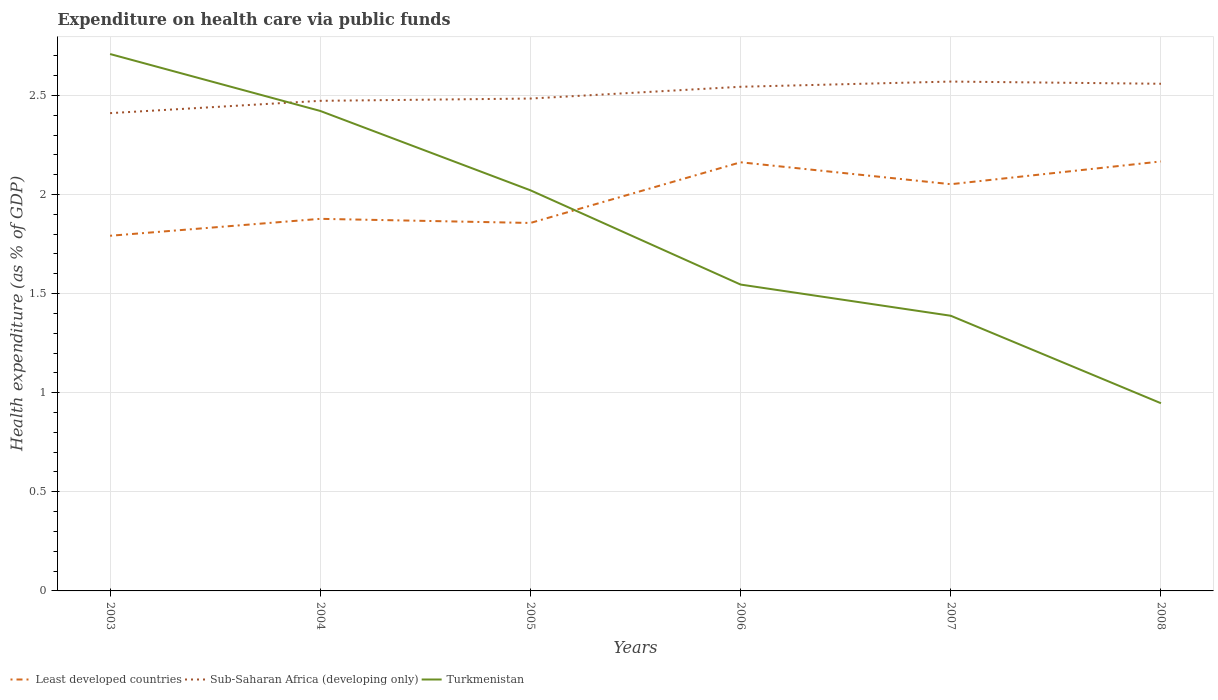How many different coloured lines are there?
Provide a short and direct response. 3. Does the line corresponding to Least developed countries intersect with the line corresponding to Sub-Saharan Africa (developing only)?
Your answer should be compact. No. Is the number of lines equal to the number of legend labels?
Offer a very short reply. Yes. Across all years, what is the maximum expenditure made on health care in Turkmenistan?
Keep it short and to the point. 0.95. What is the total expenditure made on health care in Least developed countries in the graph?
Provide a succinct answer. -0.37. What is the difference between the highest and the second highest expenditure made on health care in Least developed countries?
Make the answer very short. 0.37. Is the expenditure made on health care in Sub-Saharan Africa (developing only) strictly greater than the expenditure made on health care in Turkmenistan over the years?
Offer a very short reply. No. How many lines are there?
Keep it short and to the point. 3. Are the values on the major ticks of Y-axis written in scientific E-notation?
Keep it short and to the point. No. How many legend labels are there?
Provide a succinct answer. 3. What is the title of the graph?
Offer a very short reply. Expenditure on health care via public funds. Does "North America" appear as one of the legend labels in the graph?
Offer a terse response. No. What is the label or title of the X-axis?
Make the answer very short. Years. What is the label or title of the Y-axis?
Your response must be concise. Health expenditure (as % of GDP). What is the Health expenditure (as % of GDP) of Least developed countries in 2003?
Give a very brief answer. 1.79. What is the Health expenditure (as % of GDP) in Sub-Saharan Africa (developing only) in 2003?
Offer a very short reply. 2.41. What is the Health expenditure (as % of GDP) in Turkmenistan in 2003?
Ensure brevity in your answer.  2.71. What is the Health expenditure (as % of GDP) in Least developed countries in 2004?
Give a very brief answer. 1.88. What is the Health expenditure (as % of GDP) of Sub-Saharan Africa (developing only) in 2004?
Give a very brief answer. 2.47. What is the Health expenditure (as % of GDP) of Turkmenistan in 2004?
Make the answer very short. 2.42. What is the Health expenditure (as % of GDP) in Least developed countries in 2005?
Ensure brevity in your answer.  1.86. What is the Health expenditure (as % of GDP) in Sub-Saharan Africa (developing only) in 2005?
Provide a short and direct response. 2.48. What is the Health expenditure (as % of GDP) of Turkmenistan in 2005?
Provide a short and direct response. 2.02. What is the Health expenditure (as % of GDP) of Least developed countries in 2006?
Make the answer very short. 2.16. What is the Health expenditure (as % of GDP) of Sub-Saharan Africa (developing only) in 2006?
Your answer should be compact. 2.54. What is the Health expenditure (as % of GDP) in Turkmenistan in 2006?
Your answer should be very brief. 1.55. What is the Health expenditure (as % of GDP) in Least developed countries in 2007?
Ensure brevity in your answer.  2.05. What is the Health expenditure (as % of GDP) in Sub-Saharan Africa (developing only) in 2007?
Provide a short and direct response. 2.57. What is the Health expenditure (as % of GDP) in Turkmenistan in 2007?
Offer a very short reply. 1.39. What is the Health expenditure (as % of GDP) in Least developed countries in 2008?
Provide a short and direct response. 2.17. What is the Health expenditure (as % of GDP) in Sub-Saharan Africa (developing only) in 2008?
Give a very brief answer. 2.56. What is the Health expenditure (as % of GDP) in Turkmenistan in 2008?
Your answer should be very brief. 0.95. Across all years, what is the maximum Health expenditure (as % of GDP) in Least developed countries?
Keep it short and to the point. 2.17. Across all years, what is the maximum Health expenditure (as % of GDP) of Sub-Saharan Africa (developing only)?
Provide a succinct answer. 2.57. Across all years, what is the maximum Health expenditure (as % of GDP) of Turkmenistan?
Offer a very short reply. 2.71. Across all years, what is the minimum Health expenditure (as % of GDP) of Least developed countries?
Give a very brief answer. 1.79. Across all years, what is the minimum Health expenditure (as % of GDP) of Sub-Saharan Africa (developing only)?
Provide a succinct answer. 2.41. Across all years, what is the minimum Health expenditure (as % of GDP) of Turkmenistan?
Your answer should be compact. 0.95. What is the total Health expenditure (as % of GDP) of Least developed countries in the graph?
Your answer should be very brief. 11.91. What is the total Health expenditure (as % of GDP) of Sub-Saharan Africa (developing only) in the graph?
Keep it short and to the point. 15.04. What is the total Health expenditure (as % of GDP) of Turkmenistan in the graph?
Provide a succinct answer. 11.03. What is the difference between the Health expenditure (as % of GDP) in Least developed countries in 2003 and that in 2004?
Ensure brevity in your answer.  -0.09. What is the difference between the Health expenditure (as % of GDP) in Sub-Saharan Africa (developing only) in 2003 and that in 2004?
Give a very brief answer. -0.06. What is the difference between the Health expenditure (as % of GDP) in Turkmenistan in 2003 and that in 2004?
Offer a terse response. 0.29. What is the difference between the Health expenditure (as % of GDP) in Least developed countries in 2003 and that in 2005?
Keep it short and to the point. -0.06. What is the difference between the Health expenditure (as % of GDP) of Sub-Saharan Africa (developing only) in 2003 and that in 2005?
Provide a succinct answer. -0.07. What is the difference between the Health expenditure (as % of GDP) in Turkmenistan in 2003 and that in 2005?
Offer a terse response. 0.69. What is the difference between the Health expenditure (as % of GDP) in Least developed countries in 2003 and that in 2006?
Provide a short and direct response. -0.37. What is the difference between the Health expenditure (as % of GDP) of Sub-Saharan Africa (developing only) in 2003 and that in 2006?
Your response must be concise. -0.13. What is the difference between the Health expenditure (as % of GDP) of Turkmenistan in 2003 and that in 2006?
Keep it short and to the point. 1.16. What is the difference between the Health expenditure (as % of GDP) of Least developed countries in 2003 and that in 2007?
Provide a short and direct response. -0.26. What is the difference between the Health expenditure (as % of GDP) in Sub-Saharan Africa (developing only) in 2003 and that in 2007?
Keep it short and to the point. -0.16. What is the difference between the Health expenditure (as % of GDP) of Turkmenistan in 2003 and that in 2007?
Make the answer very short. 1.32. What is the difference between the Health expenditure (as % of GDP) of Least developed countries in 2003 and that in 2008?
Your response must be concise. -0.37. What is the difference between the Health expenditure (as % of GDP) in Sub-Saharan Africa (developing only) in 2003 and that in 2008?
Ensure brevity in your answer.  -0.15. What is the difference between the Health expenditure (as % of GDP) of Turkmenistan in 2003 and that in 2008?
Give a very brief answer. 1.76. What is the difference between the Health expenditure (as % of GDP) of Least developed countries in 2004 and that in 2005?
Give a very brief answer. 0.02. What is the difference between the Health expenditure (as % of GDP) of Sub-Saharan Africa (developing only) in 2004 and that in 2005?
Your answer should be compact. -0.01. What is the difference between the Health expenditure (as % of GDP) in Turkmenistan in 2004 and that in 2005?
Keep it short and to the point. 0.4. What is the difference between the Health expenditure (as % of GDP) in Least developed countries in 2004 and that in 2006?
Your answer should be compact. -0.29. What is the difference between the Health expenditure (as % of GDP) in Sub-Saharan Africa (developing only) in 2004 and that in 2006?
Provide a short and direct response. -0.07. What is the difference between the Health expenditure (as % of GDP) in Turkmenistan in 2004 and that in 2006?
Provide a short and direct response. 0.88. What is the difference between the Health expenditure (as % of GDP) in Least developed countries in 2004 and that in 2007?
Provide a short and direct response. -0.17. What is the difference between the Health expenditure (as % of GDP) in Sub-Saharan Africa (developing only) in 2004 and that in 2007?
Your response must be concise. -0.1. What is the difference between the Health expenditure (as % of GDP) of Least developed countries in 2004 and that in 2008?
Make the answer very short. -0.29. What is the difference between the Health expenditure (as % of GDP) in Sub-Saharan Africa (developing only) in 2004 and that in 2008?
Provide a short and direct response. -0.09. What is the difference between the Health expenditure (as % of GDP) of Turkmenistan in 2004 and that in 2008?
Make the answer very short. 1.47. What is the difference between the Health expenditure (as % of GDP) in Least developed countries in 2005 and that in 2006?
Offer a terse response. -0.31. What is the difference between the Health expenditure (as % of GDP) of Sub-Saharan Africa (developing only) in 2005 and that in 2006?
Offer a terse response. -0.06. What is the difference between the Health expenditure (as % of GDP) of Turkmenistan in 2005 and that in 2006?
Keep it short and to the point. 0.48. What is the difference between the Health expenditure (as % of GDP) in Least developed countries in 2005 and that in 2007?
Your answer should be compact. -0.2. What is the difference between the Health expenditure (as % of GDP) in Sub-Saharan Africa (developing only) in 2005 and that in 2007?
Make the answer very short. -0.09. What is the difference between the Health expenditure (as % of GDP) in Turkmenistan in 2005 and that in 2007?
Your response must be concise. 0.63. What is the difference between the Health expenditure (as % of GDP) of Least developed countries in 2005 and that in 2008?
Your response must be concise. -0.31. What is the difference between the Health expenditure (as % of GDP) in Sub-Saharan Africa (developing only) in 2005 and that in 2008?
Keep it short and to the point. -0.07. What is the difference between the Health expenditure (as % of GDP) of Turkmenistan in 2005 and that in 2008?
Make the answer very short. 1.07. What is the difference between the Health expenditure (as % of GDP) of Least developed countries in 2006 and that in 2007?
Provide a short and direct response. 0.11. What is the difference between the Health expenditure (as % of GDP) in Sub-Saharan Africa (developing only) in 2006 and that in 2007?
Provide a short and direct response. -0.03. What is the difference between the Health expenditure (as % of GDP) in Turkmenistan in 2006 and that in 2007?
Offer a very short reply. 0.16. What is the difference between the Health expenditure (as % of GDP) in Least developed countries in 2006 and that in 2008?
Your response must be concise. -0. What is the difference between the Health expenditure (as % of GDP) in Sub-Saharan Africa (developing only) in 2006 and that in 2008?
Provide a short and direct response. -0.02. What is the difference between the Health expenditure (as % of GDP) of Turkmenistan in 2006 and that in 2008?
Your answer should be compact. 0.6. What is the difference between the Health expenditure (as % of GDP) in Least developed countries in 2007 and that in 2008?
Your answer should be very brief. -0.11. What is the difference between the Health expenditure (as % of GDP) in Sub-Saharan Africa (developing only) in 2007 and that in 2008?
Provide a short and direct response. 0.01. What is the difference between the Health expenditure (as % of GDP) of Turkmenistan in 2007 and that in 2008?
Ensure brevity in your answer.  0.44. What is the difference between the Health expenditure (as % of GDP) of Least developed countries in 2003 and the Health expenditure (as % of GDP) of Sub-Saharan Africa (developing only) in 2004?
Provide a short and direct response. -0.68. What is the difference between the Health expenditure (as % of GDP) of Least developed countries in 2003 and the Health expenditure (as % of GDP) of Turkmenistan in 2004?
Your answer should be compact. -0.63. What is the difference between the Health expenditure (as % of GDP) of Sub-Saharan Africa (developing only) in 2003 and the Health expenditure (as % of GDP) of Turkmenistan in 2004?
Ensure brevity in your answer.  -0.01. What is the difference between the Health expenditure (as % of GDP) of Least developed countries in 2003 and the Health expenditure (as % of GDP) of Sub-Saharan Africa (developing only) in 2005?
Offer a very short reply. -0.69. What is the difference between the Health expenditure (as % of GDP) of Least developed countries in 2003 and the Health expenditure (as % of GDP) of Turkmenistan in 2005?
Provide a succinct answer. -0.23. What is the difference between the Health expenditure (as % of GDP) in Sub-Saharan Africa (developing only) in 2003 and the Health expenditure (as % of GDP) in Turkmenistan in 2005?
Make the answer very short. 0.39. What is the difference between the Health expenditure (as % of GDP) of Least developed countries in 2003 and the Health expenditure (as % of GDP) of Sub-Saharan Africa (developing only) in 2006?
Provide a short and direct response. -0.75. What is the difference between the Health expenditure (as % of GDP) in Least developed countries in 2003 and the Health expenditure (as % of GDP) in Turkmenistan in 2006?
Give a very brief answer. 0.25. What is the difference between the Health expenditure (as % of GDP) in Sub-Saharan Africa (developing only) in 2003 and the Health expenditure (as % of GDP) in Turkmenistan in 2006?
Ensure brevity in your answer.  0.86. What is the difference between the Health expenditure (as % of GDP) in Least developed countries in 2003 and the Health expenditure (as % of GDP) in Sub-Saharan Africa (developing only) in 2007?
Ensure brevity in your answer.  -0.78. What is the difference between the Health expenditure (as % of GDP) of Least developed countries in 2003 and the Health expenditure (as % of GDP) of Turkmenistan in 2007?
Offer a very short reply. 0.4. What is the difference between the Health expenditure (as % of GDP) of Sub-Saharan Africa (developing only) in 2003 and the Health expenditure (as % of GDP) of Turkmenistan in 2007?
Offer a very short reply. 1.02. What is the difference between the Health expenditure (as % of GDP) of Least developed countries in 2003 and the Health expenditure (as % of GDP) of Sub-Saharan Africa (developing only) in 2008?
Provide a succinct answer. -0.77. What is the difference between the Health expenditure (as % of GDP) in Least developed countries in 2003 and the Health expenditure (as % of GDP) in Turkmenistan in 2008?
Provide a short and direct response. 0.84. What is the difference between the Health expenditure (as % of GDP) of Sub-Saharan Africa (developing only) in 2003 and the Health expenditure (as % of GDP) of Turkmenistan in 2008?
Your answer should be very brief. 1.46. What is the difference between the Health expenditure (as % of GDP) of Least developed countries in 2004 and the Health expenditure (as % of GDP) of Sub-Saharan Africa (developing only) in 2005?
Make the answer very short. -0.61. What is the difference between the Health expenditure (as % of GDP) in Least developed countries in 2004 and the Health expenditure (as % of GDP) in Turkmenistan in 2005?
Ensure brevity in your answer.  -0.14. What is the difference between the Health expenditure (as % of GDP) in Sub-Saharan Africa (developing only) in 2004 and the Health expenditure (as % of GDP) in Turkmenistan in 2005?
Offer a very short reply. 0.45. What is the difference between the Health expenditure (as % of GDP) in Least developed countries in 2004 and the Health expenditure (as % of GDP) in Sub-Saharan Africa (developing only) in 2006?
Provide a short and direct response. -0.67. What is the difference between the Health expenditure (as % of GDP) of Least developed countries in 2004 and the Health expenditure (as % of GDP) of Turkmenistan in 2006?
Offer a very short reply. 0.33. What is the difference between the Health expenditure (as % of GDP) of Sub-Saharan Africa (developing only) in 2004 and the Health expenditure (as % of GDP) of Turkmenistan in 2006?
Give a very brief answer. 0.93. What is the difference between the Health expenditure (as % of GDP) in Least developed countries in 2004 and the Health expenditure (as % of GDP) in Sub-Saharan Africa (developing only) in 2007?
Make the answer very short. -0.69. What is the difference between the Health expenditure (as % of GDP) in Least developed countries in 2004 and the Health expenditure (as % of GDP) in Turkmenistan in 2007?
Provide a short and direct response. 0.49. What is the difference between the Health expenditure (as % of GDP) of Sub-Saharan Africa (developing only) in 2004 and the Health expenditure (as % of GDP) of Turkmenistan in 2007?
Provide a succinct answer. 1.08. What is the difference between the Health expenditure (as % of GDP) in Least developed countries in 2004 and the Health expenditure (as % of GDP) in Sub-Saharan Africa (developing only) in 2008?
Make the answer very short. -0.68. What is the difference between the Health expenditure (as % of GDP) in Least developed countries in 2004 and the Health expenditure (as % of GDP) in Turkmenistan in 2008?
Offer a very short reply. 0.93. What is the difference between the Health expenditure (as % of GDP) in Sub-Saharan Africa (developing only) in 2004 and the Health expenditure (as % of GDP) in Turkmenistan in 2008?
Offer a terse response. 1.53. What is the difference between the Health expenditure (as % of GDP) in Least developed countries in 2005 and the Health expenditure (as % of GDP) in Sub-Saharan Africa (developing only) in 2006?
Give a very brief answer. -0.69. What is the difference between the Health expenditure (as % of GDP) in Least developed countries in 2005 and the Health expenditure (as % of GDP) in Turkmenistan in 2006?
Ensure brevity in your answer.  0.31. What is the difference between the Health expenditure (as % of GDP) in Sub-Saharan Africa (developing only) in 2005 and the Health expenditure (as % of GDP) in Turkmenistan in 2006?
Your response must be concise. 0.94. What is the difference between the Health expenditure (as % of GDP) of Least developed countries in 2005 and the Health expenditure (as % of GDP) of Sub-Saharan Africa (developing only) in 2007?
Provide a succinct answer. -0.71. What is the difference between the Health expenditure (as % of GDP) of Least developed countries in 2005 and the Health expenditure (as % of GDP) of Turkmenistan in 2007?
Your answer should be compact. 0.47. What is the difference between the Health expenditure (as % of GDP) of Sub-Saharan Africa (developing only) in 2005 and the Health expenditure (as % of GDP) of Turkmenistan in 2007?
Offer a terse response. 1.1. What is the difference between the Health expenditure (as % of GDP) in Least developed countries in 2005 and the Health expenditure (as % of GDP) in Sub-Saharan Africa (developing only) in 2008?
Provide a succinct answer. -0.7. What is the difference between the Health expenditure (as % of GDP) of Least developed countries in 2005 and the Health expenditure (as % of GDP) of Turkmenistan in 2008?
Give a very brief answer. 0.91. What is the difference between the Health expenditure (as % of GDP) in Sub-Saharan Africa (developing only) in 2005 and the Health expenditure (as % of GDP) in Turkmenistan in 2008?
Your answer should be compact. 1.54. What is the difference between the Health expenditure (as % of GDP) in Least developed countries in 2006 and the Health expenditure (as % of GDP) in Sub-Saharan Africa (developing only) in 2007?
Your response must be concise. -0.41. What is the difference between the Health expenditure (as % of GDP) in Least developed countries in 2006 and the Health expenditure (as % of GDP) in Turkmenistan in 2007?
Offer a very short reply. 0.77. What is the difference between the Health expenditure (as % of GDP) in Sub-Saharan Africa (developing only) in 2006 and the Health expenditure (as % of GDP) in Turkmenistan in 2007?
Offer a terse response. 1.16. What is the difference between the Health expenditure (as % of GDP) of Least developed countries in 2006 and the Health expenditure (as % of GDP) of Sub-Saharan Africa (developing only) in 2008?
Your answer should be compact. -0.4. What is the difference between the Health expenditure (as % of GDP) in Least developed countries in 2006 and the Health expenditure (as % of GDP) in Turkmenistan in 2008?
Provide a short and direct response. 1.22. What is the difference between the Health expenditure (as % of GDP) in Sub-Saharan Africa (developing only) in 2006 and the Health expenditure (as % of GDP) in Turkmenistan in 2008?
Provide a short and direct response. 1.6. What is the difference between the Health expenditure (as % of GDP) of Least developed countries in 2007 and the Health expenditure (as % of GDP) of Sub-Saharan Africa (developing only) in 2008?
Offer a very short reply. -0.51. What is the difference between the Health expenditure (as % of GDP) of Least developed countries in 2007 and the Health expenditure (as % of GDP) of Turkmenistan in 2008?
Provide a short and direct response. 1.1. What is the difference between the Health expenditure (as % of GDP) in Sub-Saharan Africa (developing only) in 2007 and the Health expenditure (as % of GDP) in Turkmenistan in 2008?
Your response must be concise. 1.62. What is the average Health expenditure (as % of GDP) in Least developed countries per year?
Keep it short and to the point. 1.98. What is the average Health expenditure (as % of GDP) in Sub-Saharan Africa (developing only) per year?
Keep it short and to the point. 2.51. What is the average Health expenditure (as % of GDP) of Turkmenistan per year?
Make the answer very short. 1.84. In the year 2003, what is the difference between the Health expenditure (as % of GDP) of Least developed countries and Health expenditure (as % of GDP) of Sub-Saharan Africa (developing only)?
Offer a very short reply. -0.62. In the year 2003, what is the difference between the Health expenditure (as % of GDP) of Least developed countries and Health expenditure (as % of GDP) of Turkmenistan?
Your answer should be compact. -0.92. In the year 2003, what is the difference between the Health expenditure (as % of GDP) of Sub-Saharan Africa (developing only) and Health expenditure (as % of GDP) of Turkmenistan?
Keep it short and to the point. -0.3. In the year 2004, what is the difference between the Health expenditure (as % of GDP) in Least developed countries and Health expenditure (as % of GDP) in Sub-Saharan Africa (developing only)?
Your answer should be compact. -0.6. In the year 2004, what is the difference between the Health expenditure (as % of GDP) in Least developed countries and Health expenditure (as % of GDP) in Turkmenistan?
Your answer should be very brief. -0.54. In the year 2004, what is the difference between the Health expenditure (as % of GDP) of Sub-Saharan Africa (developing only) and Health expenditure (as % of GDP) of Turkmenistan?
Keep it short and to the point. 0.05. In the year 2005, what is the difference between the Health expenditure (as % of GDP) in Least developed countries and Health expenditure (as % of GDP) in Sub-Saharan Africa (developing only)?
Provide a short and direct response. -0.63. In the year 2005, what is the difference between the Health expenditure (as % of GDP) of Least developed countries and Health expenditure (as % of GDP) of Turkmenistan?
Provide a succinct answer. -0.16. In the year 2005, what is the difference between the Health expenditure (as % of GDP) in Sub-Saharan Africa (developing only) and Health expenditure (as % of GDP) in Turkmenistan?
Your response must be concise. 0.46. In the year 2006, what is the difference between the Health expenditure (as % of GDP) of Least developed countries and Health expenditure (as % of GDP) of Sub-Saharan Africa (developing only)?
Give a very brief answer. -0.38. In the year 2006, what is the difference between the Health expenditure (as % of GDP) of Least developed countries and Health expenditure (as % of GDP) of Turkmenistan?
Give a very brief answer. 0.62. In the year 2007, what is the difference between the Health expenditure (as % of GDP) in Least developed countries and Health expenditure (as % of GDP) in Sub-Saharan Africa (developing only)?
Your response must be concise. -0.52. In the year 2007, what is the difference between the Health expenditure (as % of GDP) of Least developed countries and Health expenditure (as % of GDP) of Turkmenistan?
Your response must be concise. 0.66. In the year 2007, what is the difference between the Health expenditure (as % of GDP) in Sub-Saharan Africa (developing only) and Health expenditure (as % of GDP) in Turkmenistan?
Provide a short and direct response. 1.18. In the year 2008, what is the difference between the Health expenditure (as % of GDP) of Least developed countries and Health expenditure (as % of GDP) of Sub-Saharan Africa (developing only)?
Provide a short and direct response. -0.39. In the year 2008, what is the difference between the Health expenditure (as % of GDP) of Least developed countries and Health expenditure (as % of GDP) of Turkmenistan?
Provide a short and direct response. 1.22. In the year 2008, what is the difference between the Health expenditure (as % of GDP) of Sub-Saharan Africa (developing only) and Health expenditure (as % of GDP) of Turkmenistan?
Make the answer very short. 1.61. What is the ratio of the Health expenditure (as % of GDP) of Least developed countries in 2003 to that in 2004?
Keep it short and to the point. 0.95. What is the ratio of the Health expenditure (as % of GDP) of Sub-Saharan Africa (developing only) in 2003 to that in 2004?
Ensure brevity in your answer.  0.97. What is the ratio of the Health expenditure (as % of GDP) in Turkmenistan in 2003 to that in 2004?
Ensure brevity in your answer.  1.12. What is the ratio of the Health expenditure (as % of GDP) of Least developed countries in 2003 to that in 2005?
Make the answer very short. 0.97. What is the ratio of the Health expenditure (as % of GDP) in Sub-Saharan Africa (developing only) in 2003 to that in 2005?
Your answer should be very brief. 0.97. What is the ratio of the Health expenditure (as % of GDP) of Turkmenistan in 2003 to that in 2005?
Your answer should be very brief. 1.34. What is the ratio of the Health expenditure (as % of GDP) of Least developed countries in 2003 to that in 2006?
Keep it short and to the point. 0.83. What is the ratio of the Health expenditure (as % of GDP) in Sub-Saharan Africa (developing only) in 2003 to that in 2006?
Make the answer very short. 0.95. What is the ratio of the Health expenditure (as % of GDP) of Turkmenistan in 2003 to that in 2006?
Provide a short and direct response. 1.75. What is the ratio of the Health expenditure (as % of GDP) of Least developed countries in 2003 to that in 2007?
Provide a succinct answer. 0.87. What is the ratio of the Health expenditure (as % of GDP) of Sub-Saharan Africa (developing only) in 2003 to that in 2007?
Offer a very short reply. 0.94. What is the ratio of the Health expenditure (as % of GDP) of Turkmenistan in 2003 to that in 2007?
Ensure brevity in your answer.  1.95. What is the ratio of the Health expenditure (as % of GDP) of Least developed countries in 2003 to that in 2008?
Offer a very short reply. 0.83. What is the ratio of the Health expenditure (as % of GDP) in Sub-Saharan Africa (developing only) in 2003 to that in 2008?
Provide a short and direct response. 0.94. What is the ratio of the Health expenditure (as % of GDP) of Turkmenistan in 2003 to that in 2008?
Ensure brevity in your answer.  2.86. What is the ratio of the Health expenditure (as % of GDP) in Least developed countries in 2004 to that in 2005?
Provide a short and direct response. 1.01. What is the ratio of the Health expenditure (as % of GDP) in Turkmenistan in 2004 to that in 2005?
Keep it short and to the point. 1.2. What is the ratio of the Health expenditure (as % of GDP) in Least developed countries in 2004 to that in 2006?
Offer a very short reply. 0.87. What is the ratio of the Health expenditure (as % of GDP) in Sub-Saharan Africa (developing only) in 2004 to that in 2006?
Give a very brief answer. 0.97. What is the ratio of the Health expenditure (as % of GDP) of Turkmenistan in 2004 to that in 2006?
Keep it short and to the point. 1.57. What is the ratio of the Health expenditure (as % of GDP) in Least developed countries in 2004 to that in 2007?
Provide a short and direct response. 0.91. What is the ratio of the Health expenditure (as % of GDP) of Sub-Saharan Africa (developing only) in 2004 to that in 2007?
Offer a very short reply. 0.96. What is the ratio of the Health expenditure (as % of GDP) of Turkmenistan in 2004 to that in 2007?
Your answer should be very brief. 1.74. What is the ratio of the Health expenditure (as % of GDP) in Least developed countries in 2004 to that in 2008?
Keep it short and to the point. 0.87. What is the ratio of the Health expenditure (as % of GDP) of Sub-Saharan Africa (developing only) in 2004 to that in 2008?
Offer a terse response. 0.97. What is the ratio of the Health expenditure (as % of GDP) in Turkmenistan in 2004 to that in 2008?
Provide a short and direct response. 2.56. What is the ratio of the Health expenditure (as % of GDP) of Least developed countries in 2005 to that in 2006?
Ensure brevity in your answer.  0.86. What is the ratio of the Health expenditure (as % of GDP) in Sub-Saharan Africa (developing only) in 2005 to that in 2006?
Provide a succinct answer. 0.98. What is the ratio of the Health expenditure (as % of GDP) of Turkmenistan in 2005 to that in 2006?
Offer a terse response. 1.31. What is the ratio of the Health expenditure (as % of GDP) in Least developed countries in 2005 to that in 2007?
Offer a very short reply. 0.9. What is the ratio of the Health expenditure (as % of GDP) of Sub-Saharan Africa (developing only) in 2005 to that in 2007?
Make the answer very short. 0.97. What is the ratio of the Health expenditure (as % of GDP) in Turkmenistan in 2005 to that in 2007?
Offer a very short reply. 1.46. What is the ratio of the Health expenditure (as % of GDP) of Least developed countries in 2005 to that in 2008?
Offer a terse response. 0.86. What is the ratio of the Health expenditure (as % of GDP) of Sub-Saharan Africa (developing only) in 2005 to that in 2008?
Your answer should be very brief. 0.97. What is the ratio of the Health expenditure (as % of GDP) in Turkmenistan in 2005 to that in 2008?
Ensure brevity in your answer.  2.13. What is the ratio of the Health expenditure (as % of GDP) in Least developed countries in 2006 to that in 2007?
Your response must be concise. 1.05. What is the ratio of the Health expenditure (as % of GDP) in Sub-Saharan Africa (developing only) in 2006 to that in 2007?
Provide a short and direct response. 0.99. What is the ratio of the Health expenditure (as % of GDP) in Turkmenistan in 2006 to that in 2007?
Your response must be concise. 1.11. What is the ratio of the Health expenditure (as % of GDP) of Least developed countries in 2006 to that in 2008?
Your response must be concise. 1. What is the ratio of the Health expenditure (as % of GDP) in Sub-Saharan Africa (developing only) in 2006 to that in 2008?
Offer a terse response. 0.99. What is the ratio of the Health expenditure (as % of GDP) of Turkmenistan in 2006 to that in 2008?
Provide a succinct answer. 1.63. What is the ratio of the Health expenditure (as % of GDP) of Least developed countries in 2007 to that in 2008?
Offer a very short reply. 0.95. What is the ratio of the Health expenditure (as % of GDP) in Sub-Saharan Africa (developing only) in 2007 to that in 2008?
Your answer should be compact. 1. What is the ratio of the Health expenditure (as % of GDP) of Turkmenistan in 2007 to that in 2008?
Keep it short and to the point. 1.47. What is the difference between the highest and the second highest Health expenditure (as % of GDP) in Least developed countries?
Your response must be concise. 0. What is the difference between the highest and the second highest Health expenditure (as % of GDP) in Sub-Saharan Africa (developing only)?
Your answer should be very brief. 0.01. What is the difference between the highest and the second highest Health expenditure (as % of GDP) of Turkmenistan?
Your answer should be very brief. 0.29. What is the difference between the highest and the lowest Health expenditure (as % of GDP) in Least developed countries?
Your answer should be very brief. 0.37. What is the difference between the highest and the lowest Health expenditure (as % of GDP) of Sub-Saharan Africa (developing only)?
Give a very brief answer. 0.16. What is the difference between the highest and the lowest Health expenditure (as % of GDP) of Turkmenistan?
Provide a succinct answer. 1.76. 